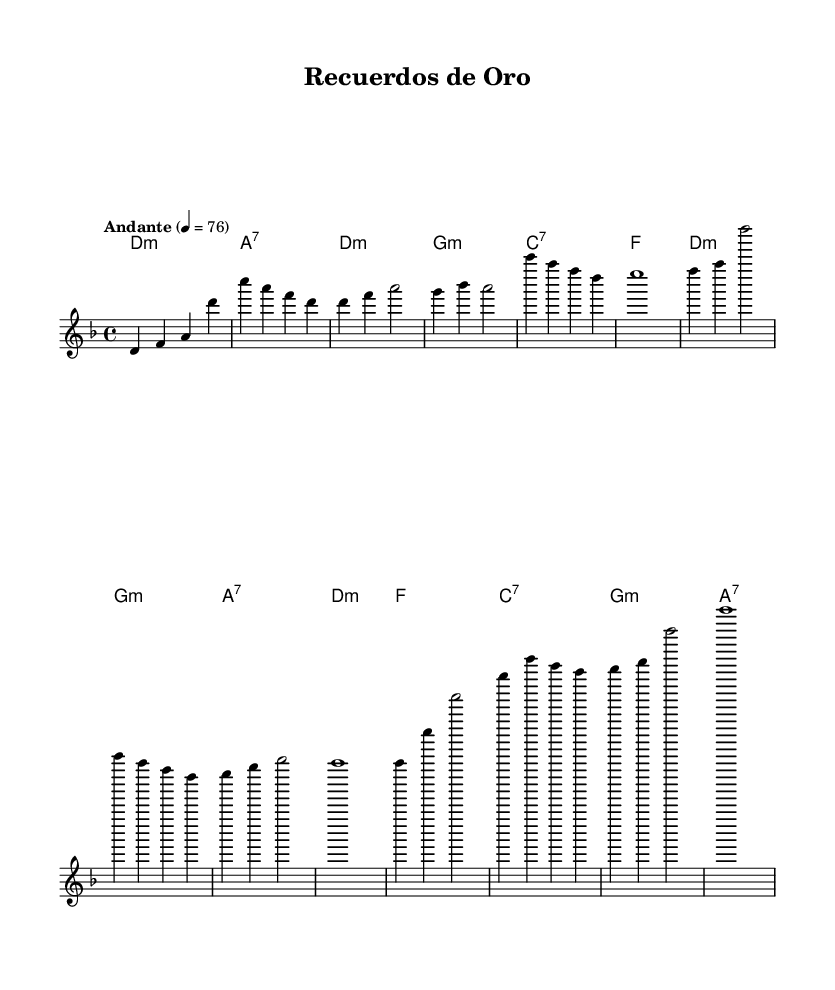What is the key signature of this music? The key signature is indicated by the symbol at the beginning of the staff. In this case, it shows two flats, corresponding to D minor.
Answer: D minor What is the time signature of this piece? The time signature is found at the beginning of the music notation. It indicates how many beats are in each measure and what note value is counted as one beat. Here, it shows 4 over 4, meaning four beats per measure with the quarter note getting one beat.
Answer: 4/4 What is the tempo marking of this composition? The tempo marking is found at the beginning of the piece. It provides the speed at which the music should be played, and in this case, it states "Andante" with a metronome marking of 76, indicating a moderate walking pace.
Answer: Andante, 76 How many bars are in the Chorus section? To determine the number of bars, we need to analyze the section marked as the chorus in the sheet music. Counting the measures, there are 4 bars in the chorus.
Answer: 4 What is the harmonic progression in the Chorus? The harmonic progression can be understood by examining the chord symbols written above the melody in the Chorus section. It follows a pattern of D minor, G minor, A7, and D minor.
Answer: D minor, G minor, A7, D minor Which section features the bridge? The bridge is identified by its distinct section in the music, indicated by separate lyrics or other markings. Here, it is marked as "Bridge" in the layout and follows the first chorus.
Answer: Bridge What type of chords are predominantly used in this ballad? By looking at the chord symbols, we can see that minor chords are primarily used in this piece, particularly in the verses and chorus. This is characteristic of Latin ballads which often convey a sense of nostalgia and sentimentality.
Answer: Minor chords 